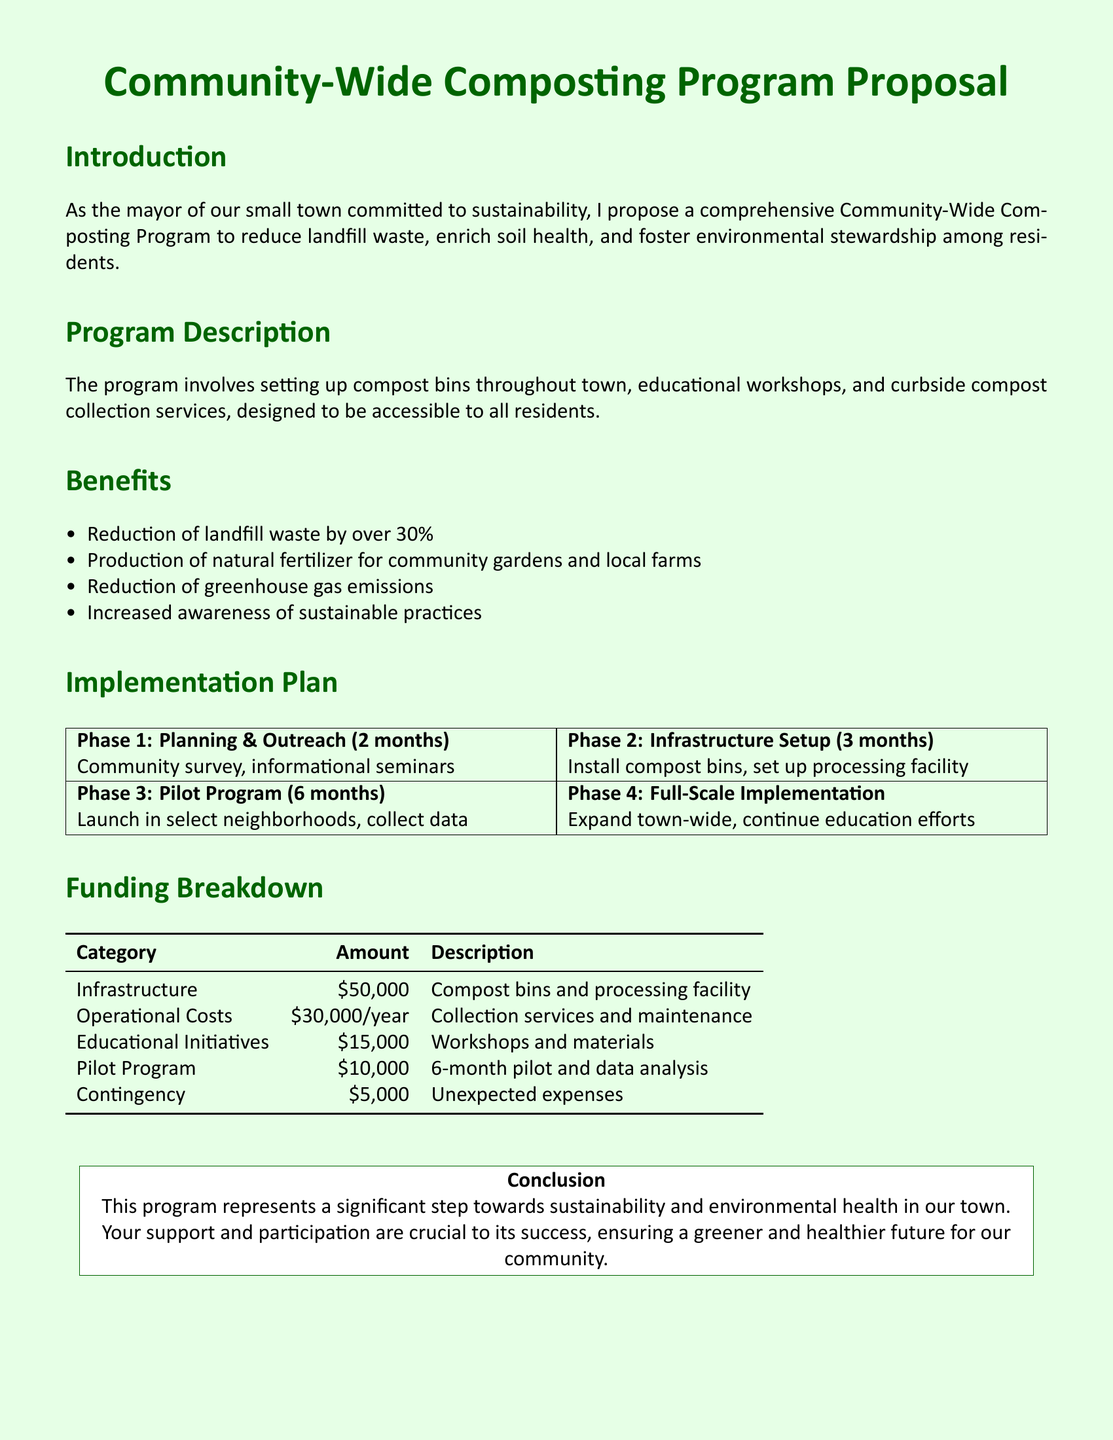what is the total funding for infrastructure? The total funding for infrastructure is specified in the funding breakdown as $50,000.
Answer: $50,000 what are the main components of the composting program? The main components are compost bins, educational workshops, and curbside compost collection services.
Answer: compost bins, workshops, curbside collection what is the duration of the pilot program? The pilot program is planned for a duration of 6 months as described in the implementation plan.
Answer: 6 months how much is allocated for educational initiatives? The amount allocated for educational initiatives is identified in the funding breakdown as $15,000.
Answer: $15,000 what is the expected reduction in landfill waste? The expected reduction in landfill waste is stated as over 30\%.
Answer: over 30% what is included in the operational costs? Operational costs include collection services and maintenance, as indicated in the funding breakdown.
Answer: collection services and maintenance what is the contingency amount for unexpected expenses? The contingency amount specified for unexpected expenses is $5,000.
Answer: $5,000 in which phase is the processing facility set up? The processing facility is set up in Phase 2: Infrastructure Setup according to the implementation plan.
Answer: Phase 2: Infrastructure Setup what is the purpose of the community survey in Phase 1? The community survey aims to gather feedback and information from residents as part of the planning and outreach stage.
Answer: gather feedback and information what is the main goal of the Community-Wide Composting Program? The main goal of the program is to reduce landfill waste, as stated in the introduction.
Answer: reduce landfill waste 